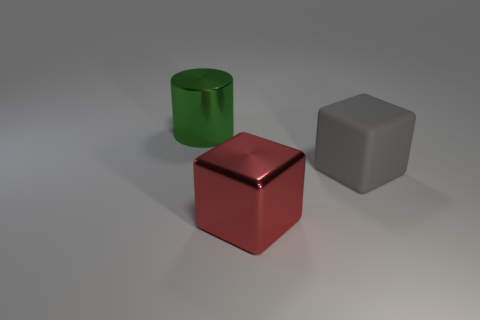Add 3 big cyan shiny cylinders. How many objects exist? 6 Subtract all red cubes. How many cubes are left? 1 Subtract 0 red balls. How many objects are left? 3 Subtract all cubes. How many objects are left? 1 Subtract 1 cylinders. How many cylinders are left? 0 Subtract all red cubes. Subtract all cyan cylinders. How many cubes are left? 1 Subtract all yellow cylinders. How many brown blocks are left? 0 Subtract all cyan shiny objects. Subtract all large metal cubes. How many objects are left? 2 Add 3 green metallic cylinders. How many green metallic cylinders are left? 4 Add 2 big cylinders. How many big cylinders exist? 3 